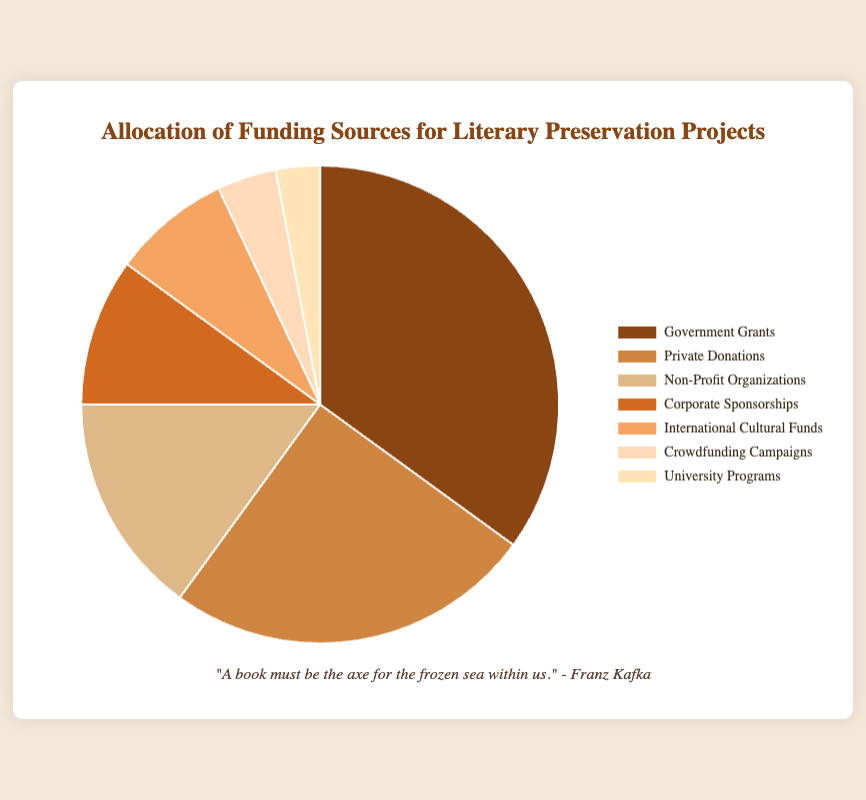What percentage of the funding is provided by Non-Profit Organizations? Locate the "Non-Profit Organizations" segment in the pie chart and check the percentage label associated with it.
Answer: 15% Which funding source has the smallest contribution to literary preservation projects? Identify the segment with the smallest percentage label in the pie chart.
Answer: University Programs How much more funding comes from Government Grants compared to Corporate Sponsorships? Find the percentages for Government Grants and Corporate Sponsorships, then subtract the latter from the former (35% - 10%).
Answer: 25% What is the combined funding percentage from Crowdfunding Campaigns and International Cultural Funds? Add the percentages of Crowdfunding Campaigns (4%) and International Cultural Funds (8%) together.
Answer: 12% Which two funding sources together contribute to 60% of the total funding? Identify the two largest segments in the pie chart and add their percentages: Government Grants (35%) and Private Donations (25%) sum to 60%.
Answer: Government Grants and Private Donations Is the contribution from Private Donations more than twice that of University Programs? Compare the percentages: Private Donations (25%) and University Programs (3%). Since 25% > 2 * 3%, the answer is yes.
Answer: Yes What is the second smallest funding source? Identify the second smallest segment in the pie chart, considering that University Programs is the smallest (3%). The next smallest is Crowdfunding Campaigns (4%).
Answer: Crowdfunding Campaigns How does the contribution percentage from International Cultural Funds compare to that from Corporate Sponsorships? Compare the percentages of International Cultural Funds (8%) and Corporate Sponsorships (10%). Since 8% < 10%, Corporate Sponsorships is larger.
Answer: Less What percentage of the funding comes from sources other than Government Grants and Private Donations? Subtract the sum of the percentages for Government Grants (35%) and Private Donations (25%) from 100% (100% - 35% - 25%).
Answer: 40% What's the difference between the highest and lowest funded sources? Find the difference between the highest (Government Grants, 35%) and lowest (University Programs, 3%) percentages.
Answer: 32% 